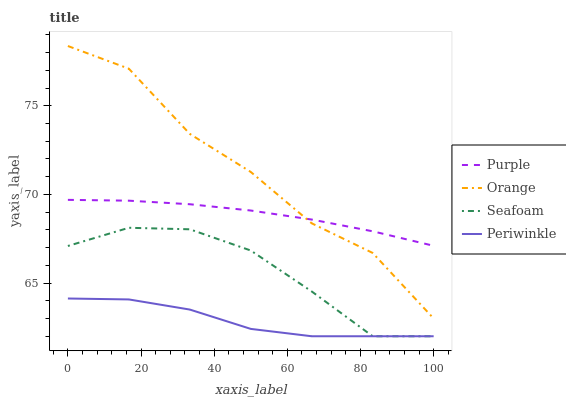Does Periwinkle have the minimum area under the curve?
Answer yes or no. Yes. Does Orange have the maximum area under the curve?
Answer yes or no. Yes. Does Orange have the minimum area under the curve?
Answer yes or no. No. Does Periwinkle have the maximum area under the curve?
Answer yes or no. No. Is Purple the smoothest?
Answer yes or no. Yes. Is Orange the roughest?
Answer yes or no. Yes. Is Periwinkle the smoothest?
Answer yes or no. No. Is Periwinkle the roughest?
Answer yes or no. No. Does Periwinkle have the lowest value?
Answer yes or no. Yes. Does Orange have the lowest value?
Answer yes or no. No. Does Orange have the highest value?
Answer yes or no. Yes. Does Periwinkle have the highest value?
Answer yes or no. No. Is Seafoam less than Purple?
Answer yes or no. Yes. Is Purple greater than Periwinkle?
Answer yes or no. Yes. Does Orange intersect Purple?
Answer yes or no. Yes. Is Orange less than Purple?
Answer yes or no. No. Is Orange greater than Purple?
Answer yes or no. No. Does Seafoam intersect Purple?
Answer yes or no. No. 